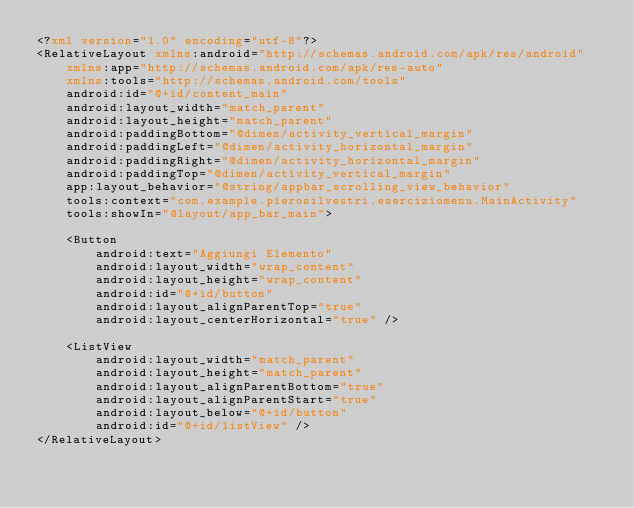<code> <loc_0><loc_0><loc_500><loc_500><_XML_><?xml version="1.0" encoding="utf-8"?>
<RelativeLayout xmlns:android="http://schemas.android.com/apk/res/android"
    xmlns:app="http://schemas.android.com/apk/res-auto"
    xmlns:tools="http://schemas.android.com/tools"
    android:id="@+id/content_main"
    android:layout_width="match_parent"
    android:layout_height="match_parent"
    android:paddingBottom="@dimen/activity_vertical_margin"
    android:paddingLeft="@dimen/activity_horizontal_margin"
    android:paddingRight="@dimen/activity_horizontal_margin"
    android:paddingTop="@dimen/activity_vertical_margin"
    app:layout_behavior="@string/appbar_scrolling_view_behavior"
    tools:context="com.example.pierosilvestri.eserciziomenu.MainActivity"
    tools:showIn="@layout/app_bar_main">

    <Button
        android:text="Aggiungi Elemento"
        android:layout_width="wrap_content"
        android:layout_height="wrap_content"
        android:id="@+id/button"
        android:layout_alignParentTop="true"
        android:layout_centerHorizontal="true" />

    <ListView
        android:layout_width="match_parent"
        android:layout_height="match_parent"
        android:layout_alignParentBottom="true"
        android:layout_alignParentStart="true"
        android:layout_below="@+id/button"
        android:id="@+id/listView" />
</RelativeLayout>
</code> 